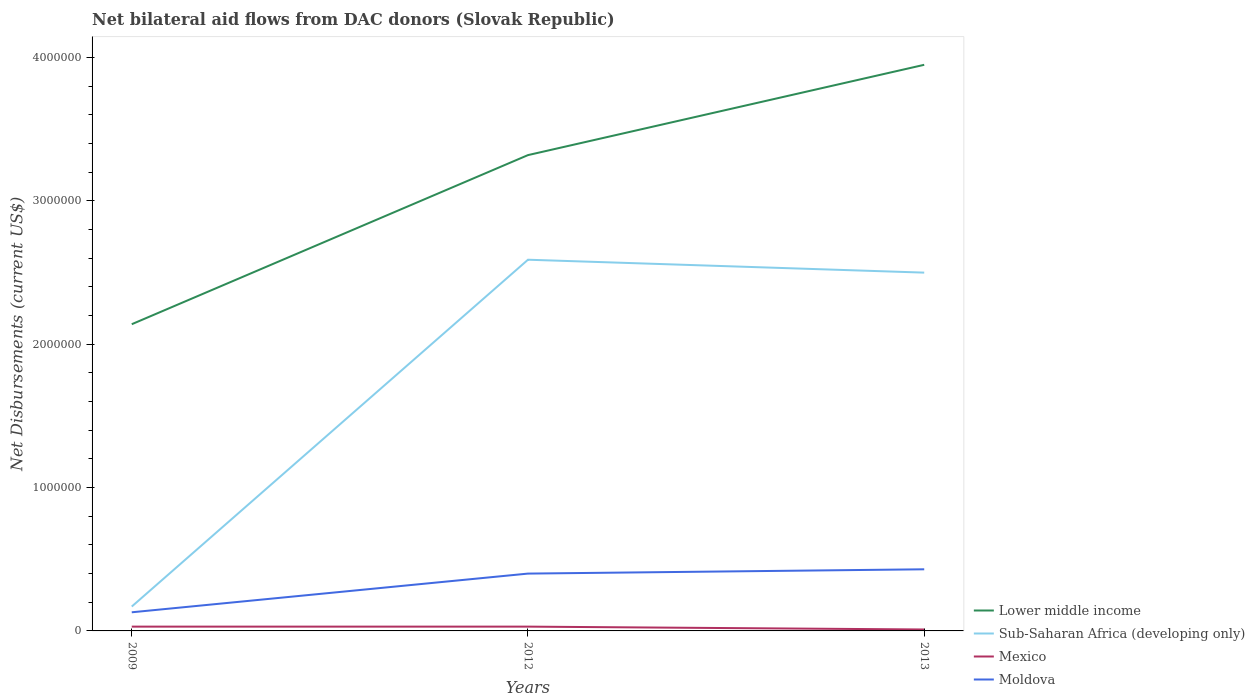How many different coloured lines are there?
Keep it short and to the point. 4. What is the difference between the highest and the lowest net bilateral aid flows in Mexico?
Make the answer very short. 2. Is the net bilateral aid flows in Lower middle income strictly greater than the net bilateral aid flows in Mexico over the years?
Make the answer very short. No. How many lines are there?
Give a very brief answer. 4. How many years are there in the graph?
Give a very brief answer. 3. What is the difference between two consecutive major ticks on the Y-axis?
Give a very brief answer. 1.00e+06. Does the graph contain any zero values?
Your answer should be very brief. No. Does the graph contain grids?
Ensure brevity in your answer.  No. Where does the legend appear in the graph?
Give a very brief answer. Bottom right. How many legend labels are there?
Give a very brief answer. 4. How are the legend labels stacked?
Provide a succinct answer. Vertical. What is the title of the graph?
Your answer should be compact. Net bilateral aid flows from DAC donors (Slovak Republic). What is the label or title of the X-axis?
Provide a short and direct response. Years. What is the label or title of the Y-axis?
Your answer should be very brief. Net Disbursements (current US$). What is the Net Disbursements (current US$) of Lower middle income in 2009?
Provide a succinct answer. 2.14e+06. What is the Net Disbursements (current US$) of Mexico in 2009?
Make the answer very short. 3.00e+04. What is the Net Disbursements (current US$) of Moldova in 2009?
Offer a very short reply. 1.30e+05. What is the Net Disbursements (current US$) in Lower middle income in 2012?
Ensure brevity in your answer.  3.32e+06. What is the Net Disbursements (current US$) in Sub-Saharan Africa (developing only) in 2012?
Make the answer very short. 2.59e+06. What is the Net Disbursements (current US$) of Lower middle income in 2013?
Provide a succinct answer. 3.95e+06. What is the Net Disbursements (current US$) of Sub-Saharan Africa (developing only) in 2013?
Offer a terse response. 2.50e+06. What is the Net Disbursements (current US$) in Mexico in 2013?
Offer a very short reply. 10000. What is the Net Disbursements (current US$) of Moldova in 2013?
Ensure brevity in your answer.  4.30e+05. Across all years, what is the maximum Net Disbursements (current US$) in Lower middle income?
Your response must be concise. 3.95e+06. Across all years, what is the maximum Net Disbursements (current US$) in Sub-Saharan Africa (developing only)?
Provide a short and direct response. 2.59e+06. Across all years, what is the maximum Net Disbursements (current US$) in Mexico?
Offer a very short reply. 3.00e+04. Across all years, what is the minimum Net Disbursements (current US$) of Lower middle income?
Make the answer very short. 2.14e+06. Across all years, what is the minimum Net Disbursements (current US$) of Mexico?
Provide a succinct answer. 10000. What is the total Net Disbursements (current US$) in Lower middle income in the graph?
Ensure brevity in your answer.  9.41e+06. What is the total Net Disbursements (current US$) in Sub-Saharan Africa (developing only) in the graph?
Keep it short and to the point. 5.26e+06. What is the total Net Disbursements (current US$) in Moldova in the graph?
Your answer should be very brief. 9.60e+05. What is the difference between the Net Disbursements (current US$) in Lower middle income in 2009 and that in 2012?
Your response must be concise. -1.18e+06. What is the difference between the Net Disbursements (current US$) in Sub-Saharan Africa (developing only) in 2009 and that in 2012?
Your answer should be compact. -2.42e+06. What is the difference between the Net Disbursements (current US$) in Moldova in 2009 and that in 2012?
Your answer should be compact. -2.70e+05. What is the difference between the Net Disbursements (current US$) of Lower middle income in 2009 and that in 2013?
Make the answer very short. -1.81e+06. What is the difference between the Net Disbursements (current US$) of Sub-Saharan Africa (developing only) in 2009 and that in 2013?
Keep it short and to the point. -2.33e+06. What is the difference between the Net Disbursements (current US$) in Mexico in 2009 and that in 2013?
Provide a short and direct response. 2.00e+04. What is the difference between the Net Disbursements (current US$) in Moldova in 2009 and that in 2013?
Make the answer very short. -3.00e+05. What is the difference between the Net Disbursements (current US$) in Lower middle income in 2012 and that in 2013?
Provide a succinct answer. -6.30e+05. What is the difference between the Net Disbursements (current US$) of Sub-Saharan Africa (developing only) in 2012 and that in 2013?
Your answer should be very brief. 9.00e+04. What is the difference between the Net Disbursements (current US$) of Lower middle income in 2009 and the Net Disbursements (current US$) of Sub-Saharan Africa (developing only) in 2012?
Provide a short and direct response. -4.50e+05. What is the difference between the Net Disbursements (current US$) in Lower middle income in 2009 and the Net Disbursements (current US$) in Mexico in 2012?
Offer a very short reply. 2.11e+06. What is the difference between the Net Disbursements (current US$) of Lower middle income in 2009 and the Net Disbursements (current US$) of Moldova in 2012?
Your response must be concise. 1.74e+06. What is the difference between the Net Disbursements (current US$) in Sub-Saharan Africa (developing only) in 2009 and the Net Disbursements (current US$) in Mexico in 2012?
Provide a short and direct response. 1.40e+05. What is the difference between the Net Disbursements (current US$) in Mexico in 2009 and the Net Disbursements (current US$) in Moldova in 2012?
Provide a short and direct response. -3.70e+05. What is the difference between the Net Disbursements (current US$) of Lower middle income in 2009 and the Net Disbursements (current US$) of Sub-Saharan Africa (developing only) in 2013?
Provide a short and direct response. -3.60e+05. What is the difference between the Net Disbursements (current US$) of Lower middle income in 2009 and the Net Disbursements (current US$) of Mexico in 2013?
Provide a succinct answer. 2.13e+06. What is the difference between the Net Disbursements (current US$) of Lower middle income in 2009 and the Net Disbursements (current US$) of Moldova in 2013?
Make the answer very short. 1.71e+06. What is the difference between the Net Disbursements (current US$) of Sub-Saharan Africa (developing only) in 2009 and the Net Disbursements (current US$) of Moldova in 2013?
Your answer should be very brief. -2.60e+05. What is the difference between the Net Disbursements (current US$) of Mexico in 2009 and the Net Disbursements (current US$) of Moldova in 2013?
Your answer should be very brief. -4.00e+05. What is the difference between the Net Disbursements (current US$) of Lower middle income in 2012 and the Net Disbursements (current US$) of Sub-Saharan Africa (developing only) in 2013?
Your answer should be very brief. 8.20e+05. What is the difference between the Net Disbursements (current US$) in Lower middle income in 2012 and the Net Disbursements (current US$) in Mexico in 2013?
Provide a short and direct response. 3.31e+06. What is the difference between the Net Disbursements (current US$) in Lower middle income in 2012 and the Net Disbursements (current US$) in Moldova in 2013?
Keep it short and to the point. 2.89e+06. What is the difference between the Net Disbursements (current US$) of Sub-Saharan Africa (developing only) in 2012 and the Net Disbursements (current US$) of Mexico in 2013?
Your response must be concise. 2.58e+06. What is the difference between the Net Disbursements (current US$) of Sub-Saharan Africa (developing only) in 2012 and the Net Disbursements (current US$) of Moldova in 2013?
Provide a short and direct response. 2.16e+06. What is the difference between the Net Disbursements (current US$) of Mexico in 2012 and the Net Disbursements (current US$) of Moldova in 2013?
Ensure brevity in your answer.  -4.00e+05. What is the average Net Disbursements (current US$) of Lower middle income per year?
Provide a short and direct response. 3.14e+06. What is the average Net Disbursements (current US$) in Sub-Saharan Africa (developing only) per year?
Your answer should be compact. 1.75e+06. What is the average Net Disbursements (current US$) of Mexico per year?
Keep it short and to the point. 2.33e+04. In the year 2009, what is the difference between the Net Disbursements (current US$) in Lower middle income and Net Disbursements (current US$) in Sub-Saharan Africa (developing only)?
Give a very brief answer. 1.97e+06. In the year 2009, what is the difference between the Net Disbursements (current US$) in Lower middle income and Net Disbursements (current US$) in Mexico?
Provide a short and direct response. 2.11e+06. In the year 2009, what is the difference between the Net Disbursements (current US$) of Lower middle income and Net Disbursements (current US$) of Moldova?
Keep it short and to the point. 2.01e+06. In the year 2009, what is the difference between the Net Disbursements (current US$) in Sub-Saharan Africa (developing only) and Net Disbursements (current US$) in Moldova?
Provide a short and direct response. 4.00e+04. In the year 2009, what is the difference between the Net Disbursements (current US$) in Mexico and Net Disbursements (current US$) in Moldova?
Ensure brevity in your answer.  -1.00e+05. In the year 2012, what is the difference between the Net Disbursements (current US$) in Lower middle income and Net Disbursements (current US$) in Sub-Saharan Africa (developing only)?
Offer a terse response. 7.30e+05. In the year 2012, what is the difference between the Net Disbursements (current US$) in Lower middle income and Net Disbursements (current US$) in Mexico?
Keep it short and to the point. 3.29e+06. In the year 2012, what is the difference between the Net Disbursements (current US$) of Lower middle income and Net Disbursements (current US$) of Moldova?
Provide a succinct answer. 2.92e+06. In the year 2012, what is the difference between the Net Disbursements (current US$) of Sub-Saharan Africa (developing only) and Net Disbursements (current US$) of Mexico?
Ensure brevity in your answer.  2.56e+06. In the year 2012, what is the difference between the Net Disbursements (current US$) of Sub-Saharan Africa (developing only) and Net Disbursements (current US$) of Moldova?
Give a very brief answer. 2.19e+06. In the year 2012, what is the difference between the Net Disbursements (current US$) in Mexico and Net Disbursements (current US$) in Moldova?
Give a very brief answer. -3.70e+05. In the year 2013, what is the difference between the Net Disbursements (current US$) of Lower middle income and Net Disbursements (current US$) of Sub-Saharan Africa (developing only)?
Offer a terse response. 1.45e+06. In the year 2013, what is the difference between the Net Disbursements (current US$) in Lower middle income and Net Disbursements (current US$) in Mexico?
Ensure brevity in your answer.  3.94e+06. In the year 2013, what is the difference between the Net Disbursements (current US$) in Lower middle income and Net Disbursements (current US$) in Moldova?
Ensure brevity in your answer.  3.52e+06. In the year 2013, what is the difference between the Net Disbursements (current US$) in Sub-Saharan Africa (developing only) and Net Disbursements (current US$) in Mexico?
Give a very brief answer. 2.49e+06. In the year 2013, what is the difference between the Net Disbursements (current US$) in Sub-Saharan Africa (developing only) and Net Disbursements (current US$) in Moldova?
Offer a very short reply. 2.07e+06. In the year 2013, what is the difference between the Net Disbursements (current US$) of Mexico and Net Disbursements (current US$) of Moldova?
Provide a short and direct response. -4.20e+05. What is the ratio of the Net Disbursements (current US$) of Lower middle income in 2009 to that in 2012?
Ensure brevity in your answer.  0.64. What is the ratio of the Net Disbursements (current US$) of Sub-Saharan Africa (developing only) in 2009 to that in 2012?
Offer a terse response. 0.07. What is the ratio of the Net Disbursements (current US$) in Moldova in 2009 to that in 2012?
Offer a very short reply. 0.33. What is the ratio of the Net Disbursements (current US$) in Lower middle income in 2009 to that in 2013?
Provide a succinct answer. 0.54. What is the ratio of the Net Disbursements (current US$) of Sub-Saharan Africa (developing only) in 2009 to that in 2013?
Make the answer very short. 0.07. What is the ratio of the Net Disbursements (current US$) of Moldova in 2009 to that in 2013?
Your answer should be very brief. 0.3. What is the ratio of the Net Disbursements (current US$) in Lower middle income in 2012 to that in 2013?
Provide a succinct answer. 0.84. What is the ratio of the Net Disbursements (current US$) of Sub-Saharan Africa (developing only) in 2012 to that in 2013?
Offer a terse response. 1.04. What is the ratio of the Net Disbursements (current US$) of Mexico in 2012 to that in 2013?
Give a very brief answer. 3. What is the ratio of the Net Disbursements (current US$) of Moldova in 2012 to that in 2013?
Ensure brevity in your answer.  0.93. What is the difference between the highest and the second highest Net Disbursements (current US$) of Lower middle income?
Your answer should be very brief. 6.30e+05. What is the difference between the highest and the second highest Net Disbursements (current US$) of Sub-Saharan Africa (developing only)?
Your response must be concise. 9.00e+04. What is the difference between the highest and the second highest Net Disbursements (current US$) of Mexico?
Offer a terse response. 0. What is the difference between the highest and the second highest Net Disbursements (current US$) in Moldova?
Provide a succinct answer. 3.00e+04. What is the difference between the highest and the lowest Net Disbursements (current US$) in Lower middle income?
Your answer should be very brief. 1.81e+06. What is the difference between the highest and the lowest Net Disbursements (current US$) of Sub-Saharan Africa (developing only)?
Offer a terse response. 2.42e+06. 